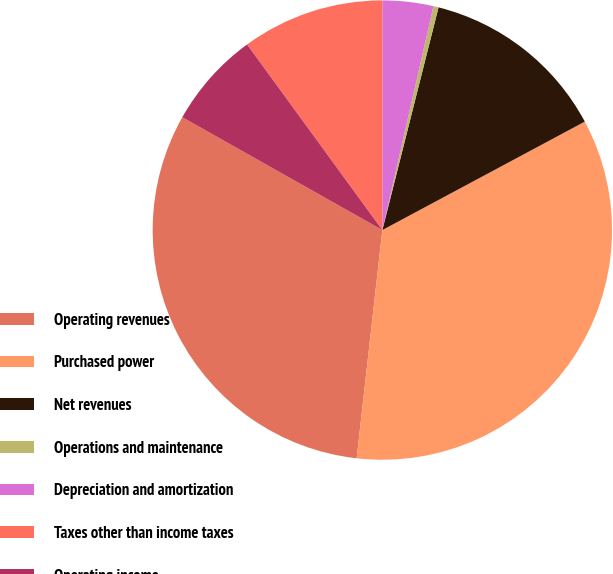Convert chart to OTSL. <chart><loc_0><loc_0><loc_500><loc_500><pie_chart><fcel>Operating revenues<fcel>Purchased power<fcel>Net revenues<fcel>Operations and maintenance<fcel>Depreciation and amortization<fcel>Taxes other than income taxes<fcel>Operating income<nl><fcel>31.39%<fcel>34.61%<fcel>13.24%<fcel>0.36%<fcel>3.58%<fcel>10.02%<fcel>6.8%<nl></chart> 